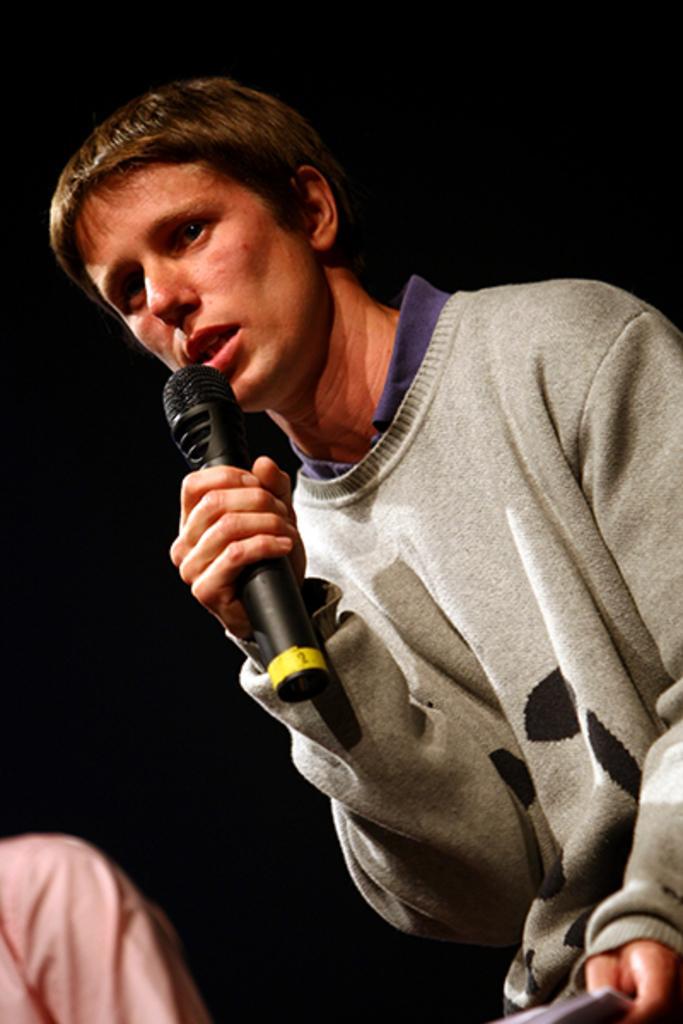How would you summarize this image in a sentence or two? In this picture a man is talking with the help of the microphone. 